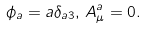Convert formula to latex. <formula><loc_0><loc_0><loc_500><loc_500>\phi _ { a } = a \delta _ { a 3 } , \, A _ { \mu } ^ { a } = 0 .</formula> 